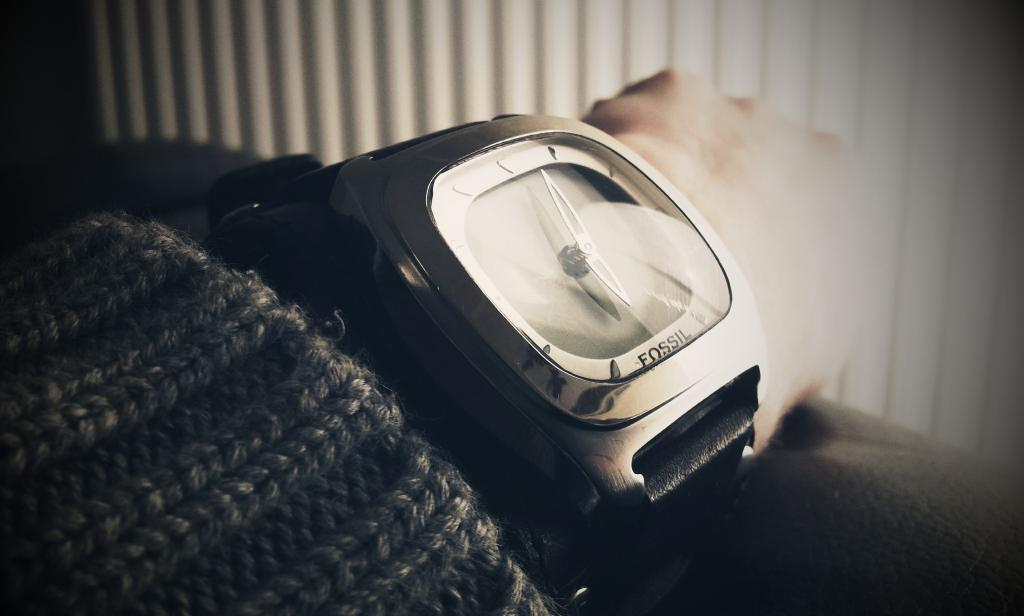<image>
Render a clear and concise summary of the photo. Person wearing a watch that says the word FOSSIL on the bottom. 